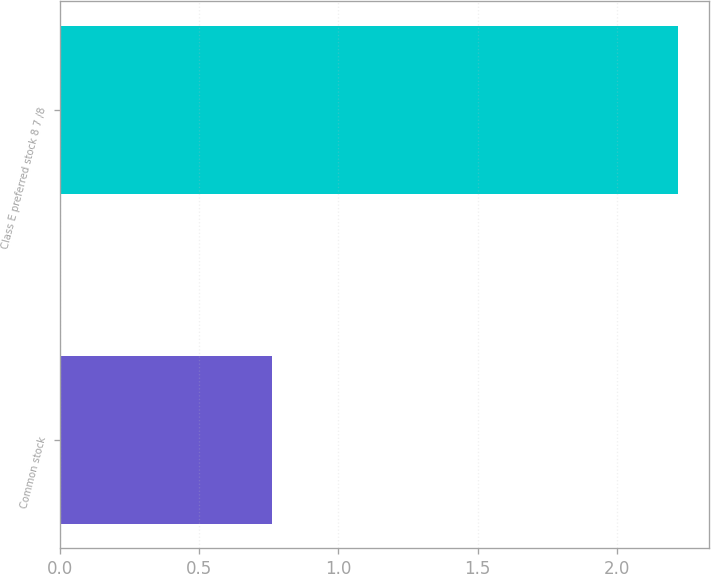<chart> <loc_0><loc_0><loc_500><loc_500><bar_chart><fcel>Common stock<fcel>Class E preferred stock 8 7 /8<nl><fcel>0.76<fcel>2.22<nl></chart> 